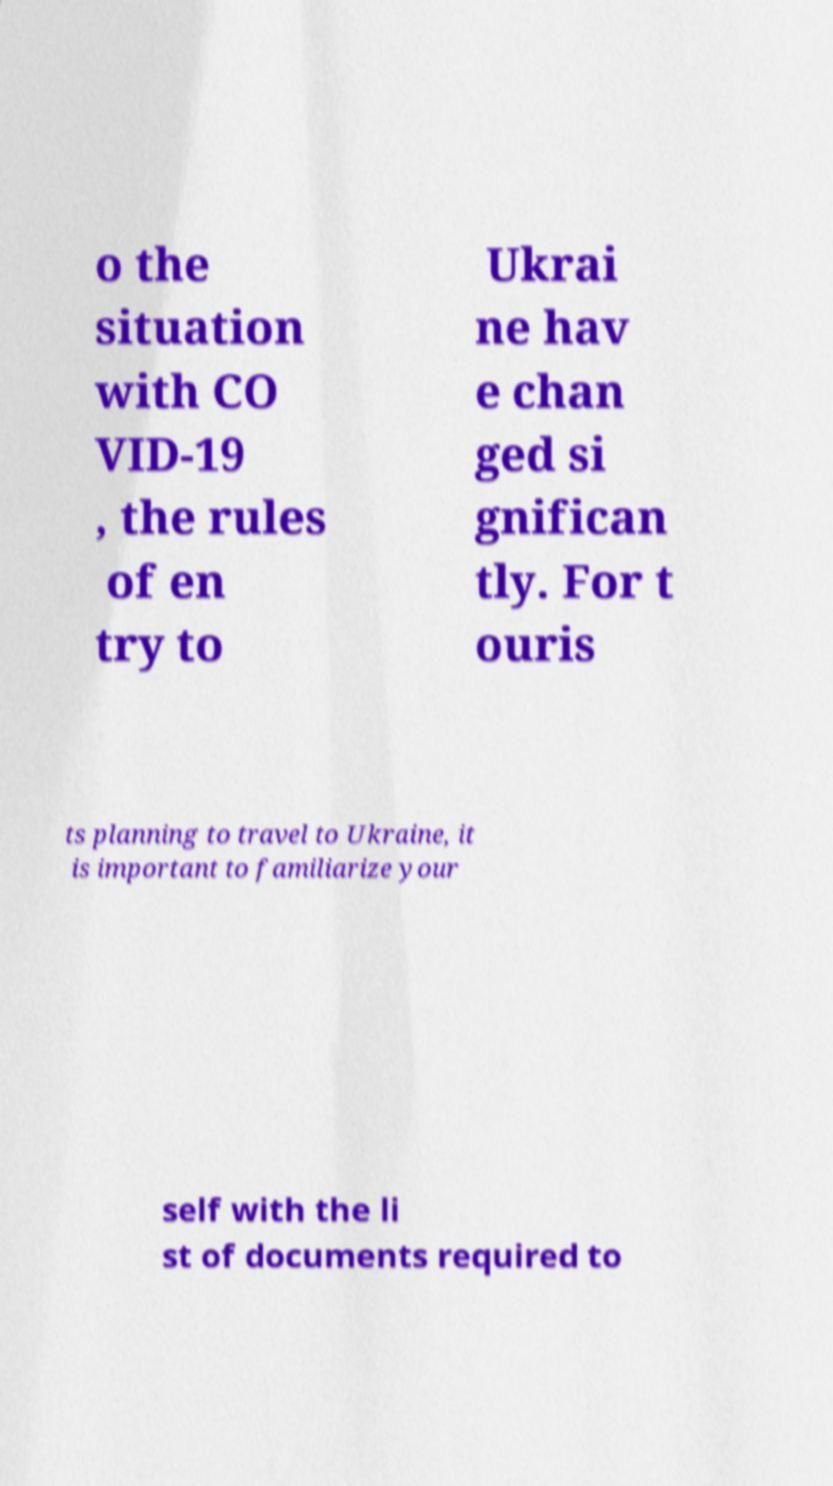Could you assist in decoding the text presented in this image and type it out clearly? o the situation with CO VID-19 , the rules of en try to Ukrai ne hav e chan ged si gnifican tly. For t ouris ts planning to travel to Ukraine, it is important to familiarize your self with the li st of documents required to 